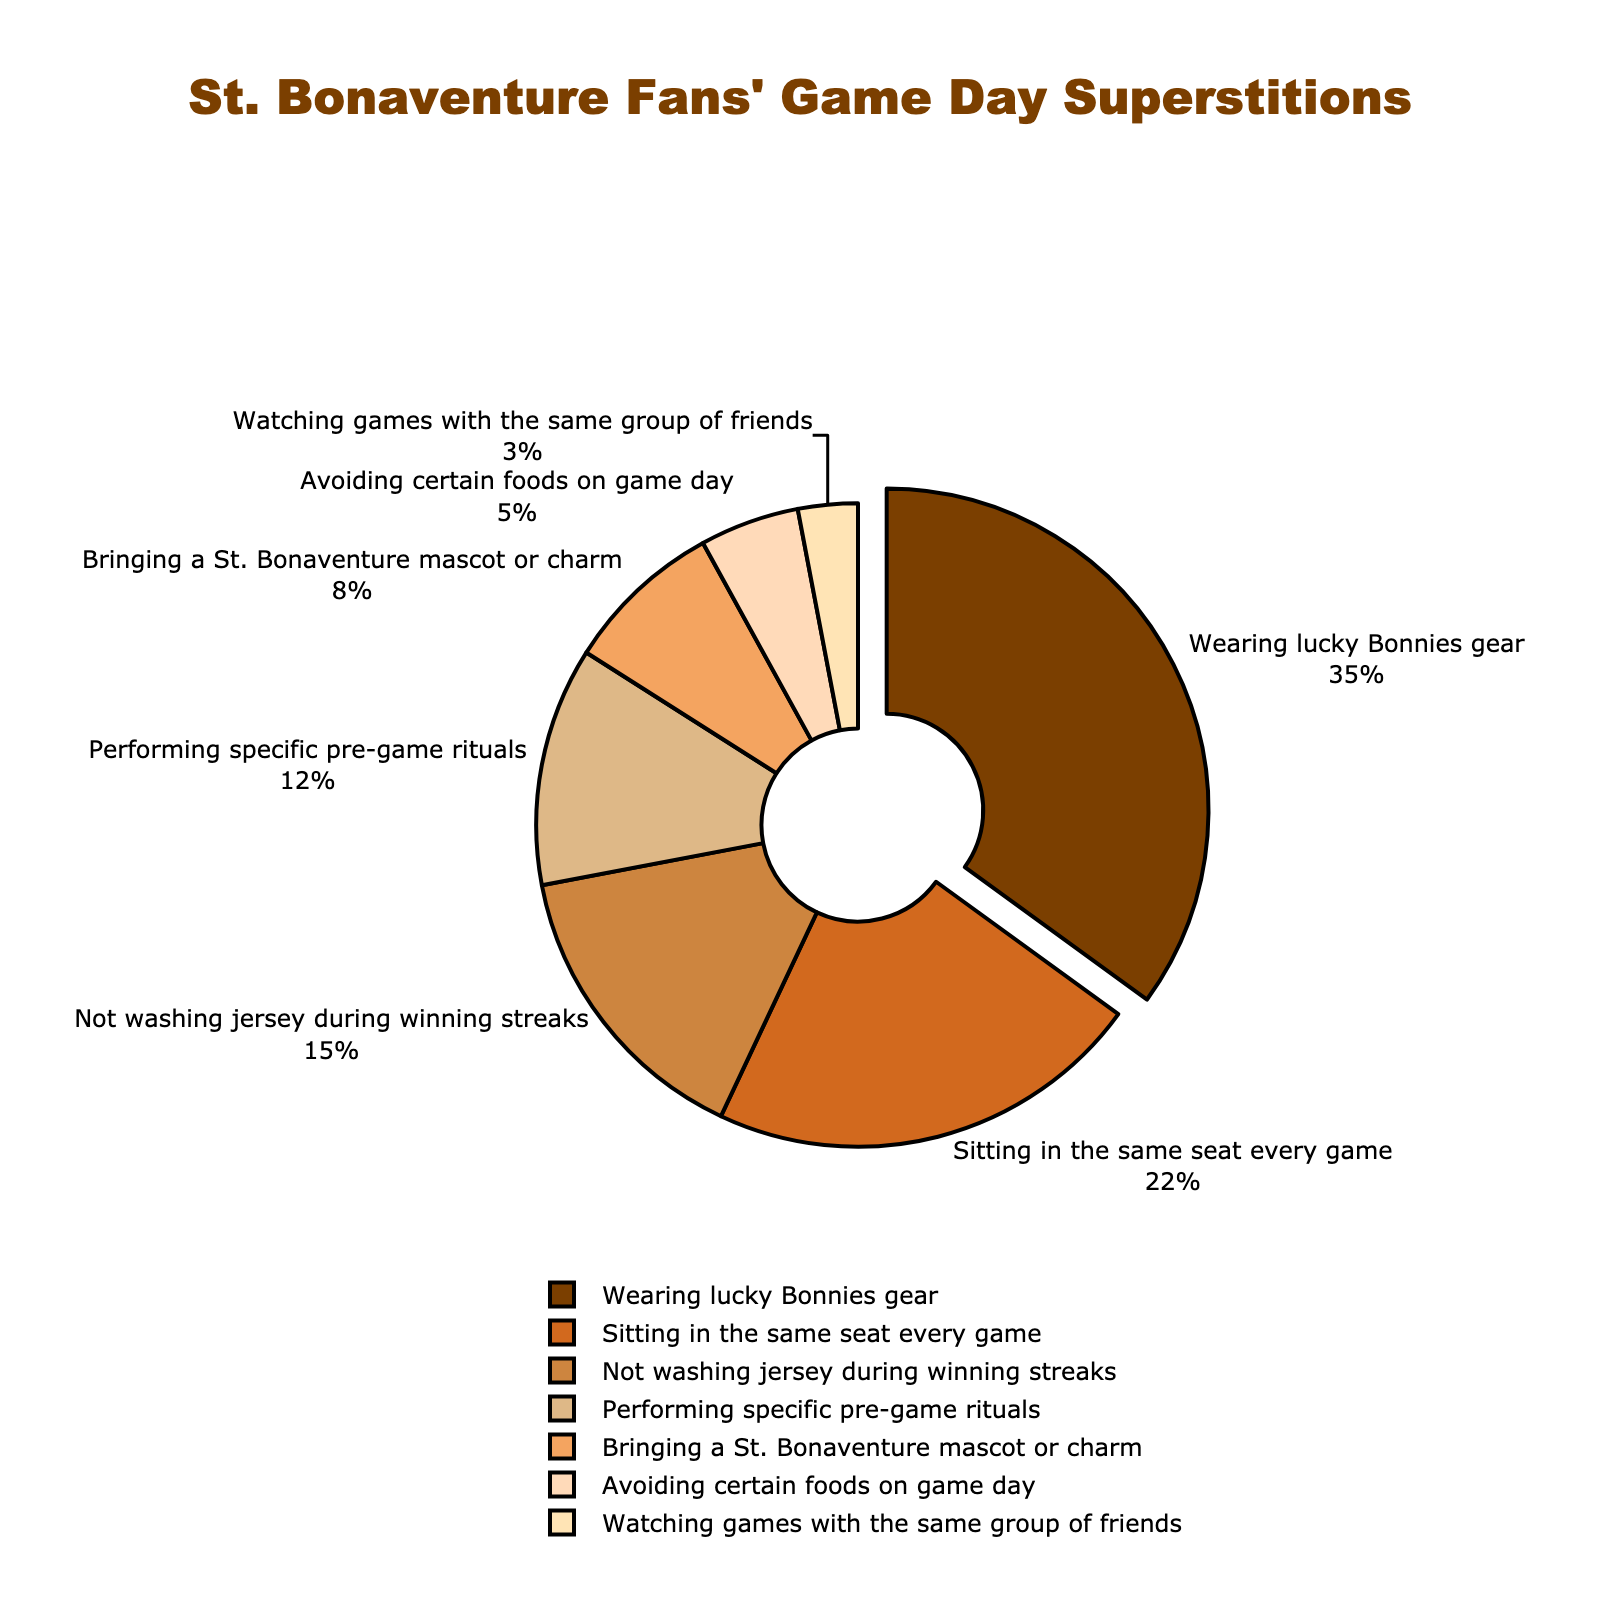What percentage of fans practice the superstition of performing specific pre-game rituals? The chart shows that the superstition of performing specific pre-game rituals occupies a section labeled with its percentage value. Find this specific sector.
Answer: 12% Which superstition is the most common among St. Bonaventure fans? Identify the largest section of the pie chart and read the superstition it represents.
Answer: Wearing lucky Bonnies gear What is the combined percentage of fans who either avoid certain foods on game day or watch games with the same group of friends? Find the percentages for "Avoiding certain foods on game day" and "Watching games with the same group of friends," then add them together.
Answer: 5% + 3% = 8% How much larger is the percentage of fans sitting in the same seat every game compared to those bringing a St. Bonaventure mascot or charm? Identify the percentages for both superstitions, and subtract the smaller percentage from the larger percentage.
Answer: 22% - 8% = 14% Which two superstitions together account for more than half of the total percentage? Identify the two largest sections of the pie chart and add their percentages to see if the sum exceeds 50%.
Answer: Wearing lucky Bonnies gear (35%) and Sitting in the same seat every game (22%). 35% + 22% = 57%, which is more than half What is the visual difference between the segment representing "Wearing lucky Bonnies gear" and other segments? Observe the pie chart for any unique visual attributes given to the "Wearing lucky Bonnies gear" segment compared to the others, such as its position, color, or if it is pulled out slightly.
Answer: The segment "Wearing lucky Bonnies gear" is slightly pulled out from the pie chart Which superstition is represented by the lightest color on the chart? Identify the section with the lightest shade and read the superstition it represents.
Answer: Watching games with the same group of friends How much smaller is the percentage of fans who avoid certain foods on game day compared to those who don't wash jerseys during winning streaks? Find the percentages for both superstitions, and subtract the smaller percentage from the larger percentage.
Answer: 15% - 5% = 10% What is the third most common superstition according to the chart? Identify the sections and their percentages, then find the one with the third highest percentage.
Answer: Not washing jersey during winning streaks 